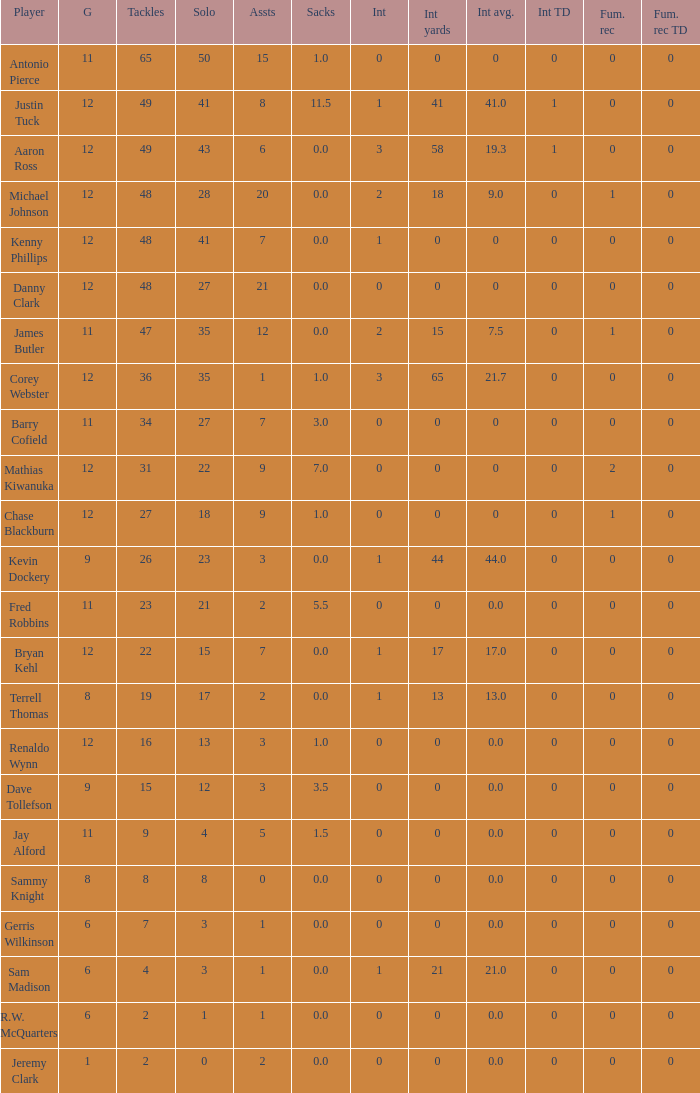Mention the lowest fum rec td. 0.0. Could you parse the entire table as a dict? {'header': ['Player', 'G', 'Tackles', 'Solo', 'Assts', 'Sacks', 'Int', 'Int yards', 'Int avg.', 'Int TD', 'Fum. rec', 'Fum. rec TD'], 'rows': [['Antonio Pierce', '11', '65', '50', '15', '1.0', '0', '0', '0', '0', '0', '0'], ['Justin Tuck', '12', '49', '41', '8', '11.5', '1', '41', '41.0', '1', '0', '0'], ['Aaron Ross', '12', '49', '43', '6', '0.0', '3', '58', '19.3', '1', '0', '0'], ['Michael Johnson', '12', '48', '28', '20', '0.0', '2', '18', '9.0', '0', '1', '0'], ['Kenny Phillips', '12', '48', '41', '7', '0.0', '1', '0', '0', '0', '0', '0'], ['Danny Clark', '12', '48', '27', '21', '0.0', '0', '0', '0', '0', '0', '0'], ['James Butler', '11', '47', '35', '12', '0.0', '2', '15', '7.5', '0', '1', '0'], ['Corey Webster', '12', '36', '35', '1', '1.0', '3', '65', '21.7', '0', '0', '0'], ['Barry Cofield', '11', '34', '27', '7', '3.0', '0', '0', '0', '0', '0', '0'], ['Mathias Kiwanuka', '12', '31', '22', '9', '7.0', '0', '0', '0', '0', '2', '0'], ['Chase Blackburn', '12', '27', '18', '9', '1.0', '0', '0', '0', '0', '1', '0'], ['Kevin Dockery', '9', '26', '23', '3', '0.0', '1', '44', '44.0', '0', '0', '0'], ['Fred Robbins', '11', '23', '21', '2', '5.5', '0', '0', '0.0', '0', '0', '0'], ['Bryan Kehl', '12', '22', '15', '7', '0.0', '1', '17', '17.0', '0', '0', '0'], ['Terrell Thomas', '8', '19', '17', '2', '0.0', '1', '13', '13.0', '0', '0', '0'], ['Renaldo Wynn', '12', '16', '13', '3', '1.0', '0', '0', '0.0', '0', '0', '0'], ['Dave Tollefson', '9', '15', '12', '3', '3.5', '0', '0', '0.0', '0', '0', '0'], ['Jay Alford', '11', '9', '4', '5', '1.5', '0', '0', '0.0', '0', '0', '0'], ['Sammy Knight', '8', '8', '8', '0', '0.0', '0', '0', '0.0', '0', '0', '0'], ['Gerris Wilkinson', '6', '7', '3', '1', '0.0', '0', '0', '0.0', '0', '0', '0'], ['Sam Madison', '6', '4', '3', '1', '0.0', '1', '21', '21.0', '0', '0', '0'], ['R.W. McQuarters', '6', '2', '1', '1', '0.0', '0', '0', '0.0', '0', '0', '0'], ['Jeremy Clark', '1', '2', '0', '2', '0.0', '0', '0', '0.0', '0', '0', '0']]} 